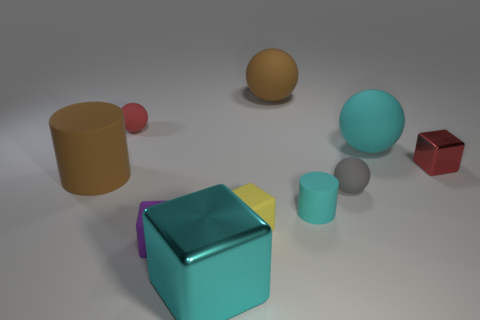How many objects are cyan things left of the large cyan matte ball or large cyan matte things?
Ensure brevity in your answer.  3. What number of purple things are large matte balls or cylinders?
Keep it short and to the point. 0. What number of other objects are the same color as the large metal block?
Provide a succinct answer. 2. Are there fewer tiny yellow things behind the big cyan matte thing than tiny red rubber balls?
Ensure brevity in your answer.  Yes. There is a small ball on the left side of the cyan rubber thing to the left of the big rubber sphere that is right of the small cyan matte object; what is its color?
Make the answer very short. Red. Is there anything else that is the same material as the gray object?
Provide a short and direct response. Yes. There is another matte object that is the same shape as the yellow rubber thing; what size is it?
Offer a terse response. Small. Are there fewer tiny rubber things right of the red sphere than metallic objects that are to the right of the cyan rubber sphere?
Your response must be concise. No. The thing that is both right of the tiny cyan rubber cylinder and behind the small red block has what shape?
Ensure brevity in your answer.  Sphere. There is a gray ball that is made of the same material as the large brown cylinder; what size is it?
Keep it short and to the point. Small. 